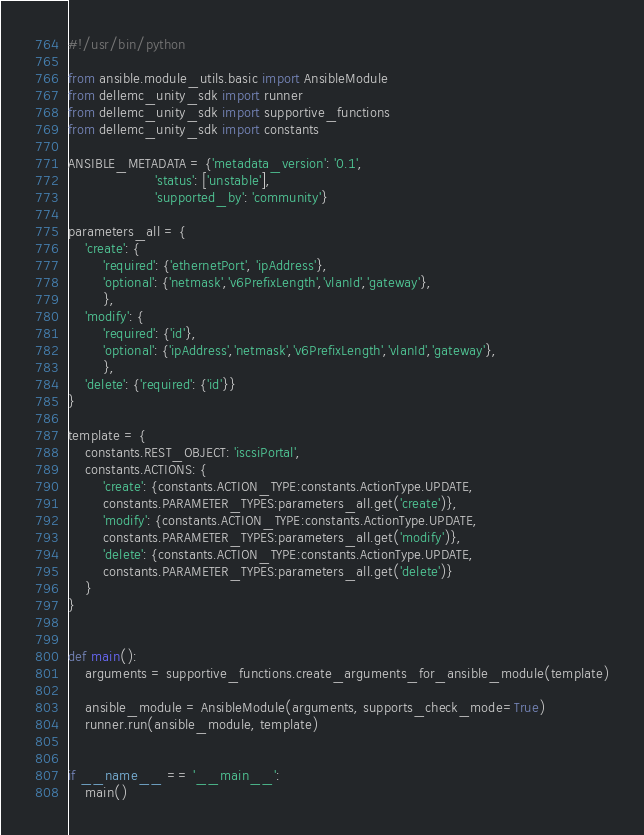<code> <loc_0><loc_0><loc_500><loc_500><_Python_>#!/usr/bin/python

from ansible.module_utils.basic import AnsibleModule
from dellemc_unity_sdk import runner
from dellemc_unity_sdk import supportive_functions
from dellemc_unity_sdk import constants

ANSIBLE_METADATA = {'metadata_version': '0.1',
                    'status': ['unstable'],
                    'supported_by': 'community'}

parameters_all = {
    'create': {
        'required': {'ethernetPort', 'ipAddress'},
        'optional': {'netmask','v6PrefixLength','vlanId','gateway'},
        },
    'modify': {
        'required': {'id'},
        'optional': {'ipAddress','netmask','v6PrefixLength','vlanId','gateway'},
        },
    'delete': {'required': {'id'}}
}

template = {
    constants.REST_OBJECT: 'iscsiPortal',
    constants.ACTIONS: {
        'create': {constants.ACTION_TYPE:constants.ActionType.UPDATE,
        constants.PARAMETER_TYPES:parameters_all.get('create')},
        'modify': {constants.ACTION_TYPE:constants.ActionType.UPDATE,
        constants.PARAMETER_TYPES:parameters_all.get('modify')},
        'delete': {constants.ACTION_TYPE:constants.ActionType.UPDATE,
        constants.PARAMETER_TYPES:parameters_all.get('delete')}
    }
}


def main():
    arguments = supportive_functions.create_arguments_for_ansible_module(template)

    ansible_module = AnsibleModule(arguments, supports_check_mode=True)
    runner.run(ansible_module, template)


if __name__ == '__main__':
    main()
</code> 